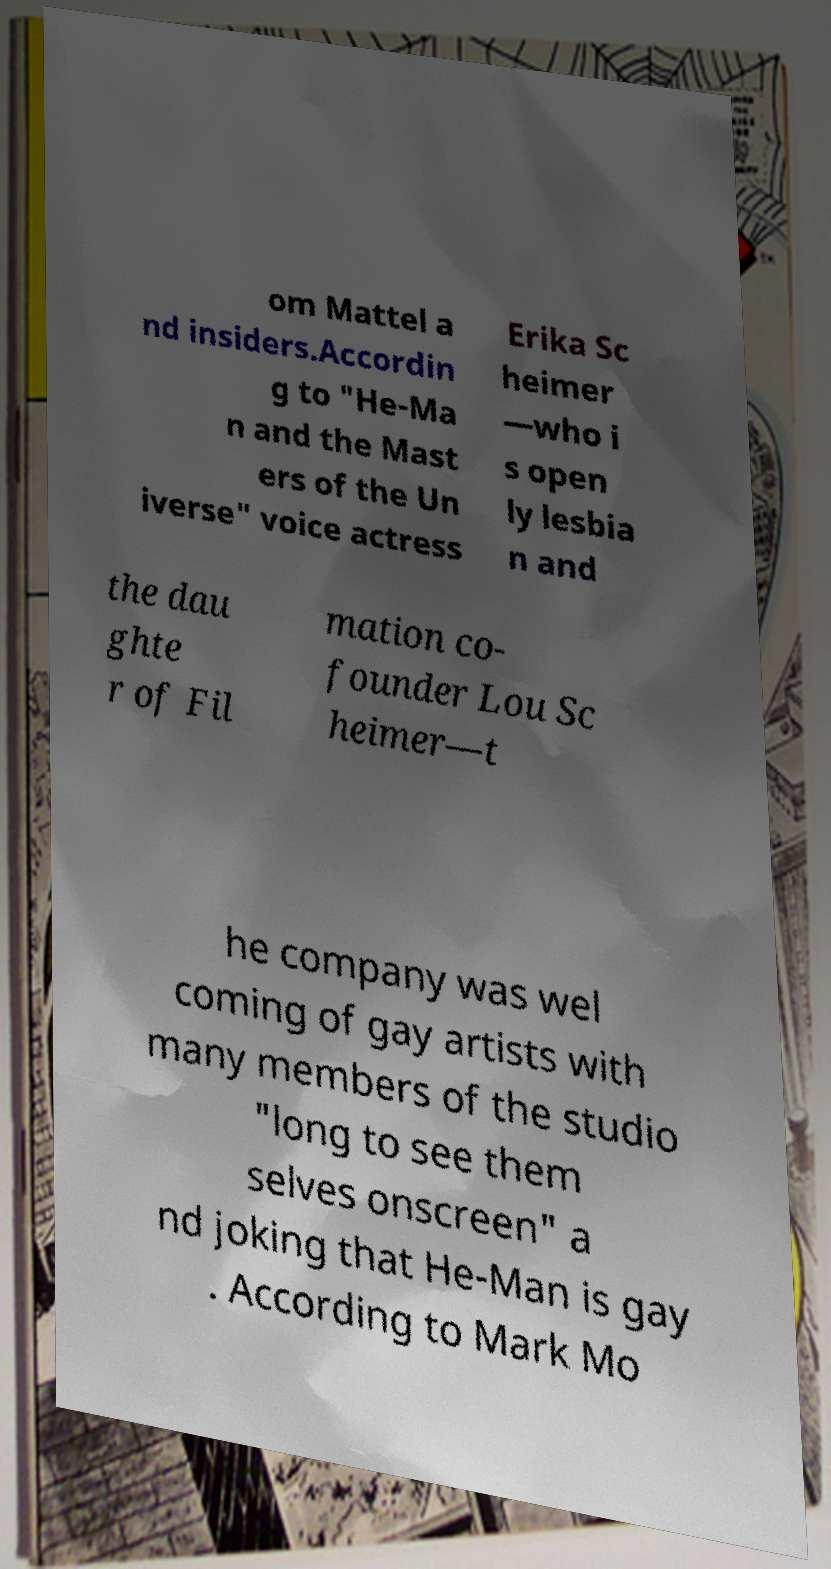Please read and relay the text visible in this image. What does it say? om Mattel a nd insiders.Accordin g to "He-Ma n and the Mast ers of the Un iverse" voice actress Erika Sc heimer —who i s open ly lesbia n and the dau ghte r of Fil mation co- founder Lou Sc heimer—t he company was wel coming of gay artists with many members of the studio "long to see them selves onscreen" a nd joking that He-Man is gay . According to Mark Mo 